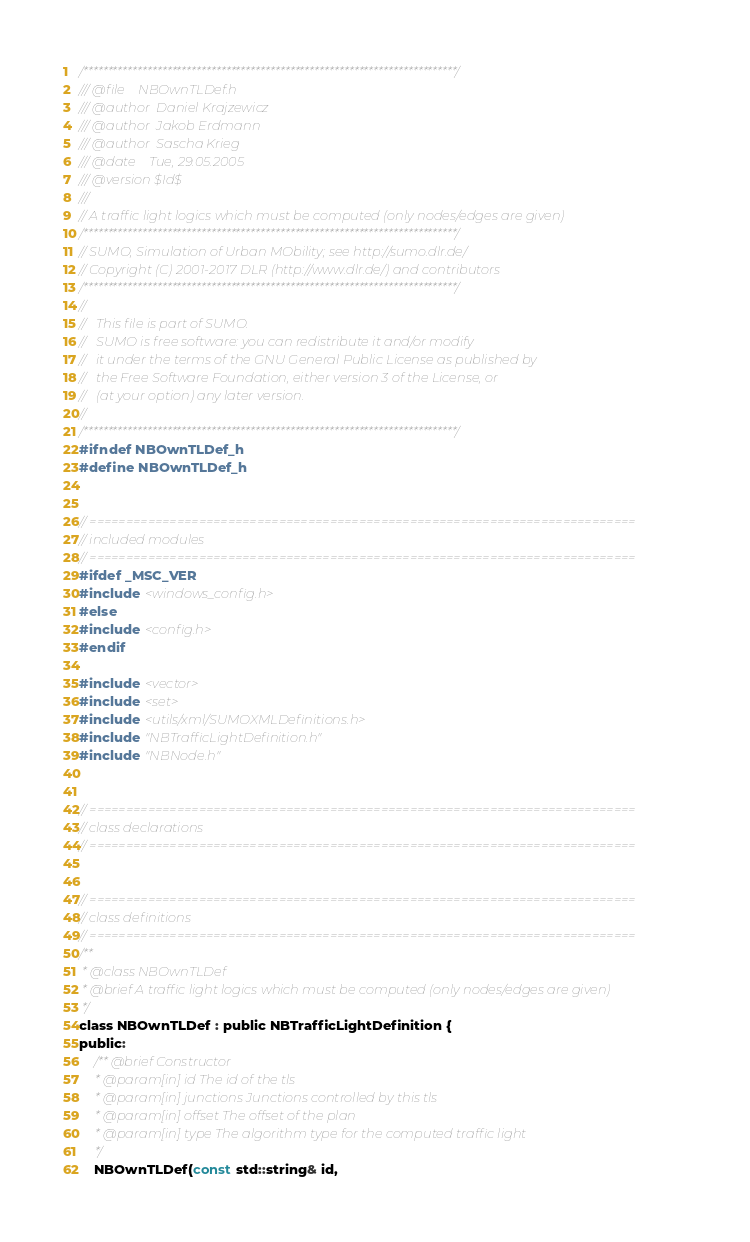<code> <loc_0><loc_0><loc_500><loc_500><_C_>/****************************************************************************/
/// @file    NBOwnTLDef.h
/// @author  Daniel Krajzewicz
/// @author  Jakob Erdmann
/// @author  Sascha Krieg
/// @date    Tue, 29.05.2005
/// @version $Id$
///
// A traffic light logics which must be computed (only nodes/edges are given)
/****************************************************************************/
// SUMO, Simulation of Urban MObility; see http://sumo.dlr.de/
// Copyright (C) 2001-2017 DLR (http://www.dlr.de/) and contributors
/****************************************************************************/
//
//   This file is part of SUMO.
//   SUMO is free software: you can redistribute it and/or modify
//   it under the terms of the GNU General Public License as published by
//   the Free Software Foundation, either version 3 of the License, or
//   (at your option) any later version.
//
/****************************************************************************/
#ifndef NBOwnTLDef_h
#define NBOwnTLDef_h


// ===========================================================================
// included modules
// ===========================================================================
#ifdef _MSC_VER
#include <windows_config.h>
#else
#include <config.h>
#endif

#include <vector>
#include <set>
#include <utils/xml/SUMOXMLDefinitions.h>
#include "NBTrafficLightDefinition.h"
#include "NBNode.h"


// ===========================================================================
// class declarations
// ===========================================================================


// ===========================================================================
// class definitions
// ===========================================================================
/**
 * @class NBOwnTLDef
 * @brief A traffic light logics which must be computed (only nodes/edges are given)
 */
class NBOwnTLDef : public NBTrafficLightDefinition {
public:
    /** @brief Constructor
     * @param[in] id The id of the tls
     * @param[in] junctions Junctions controlled by this tls
     * @param[in] offset The offset of the plan
     * @param[in] type The algorithm type for the computed traffic light
     */
    NBOwnTLDef(const std::string& id,</code> 